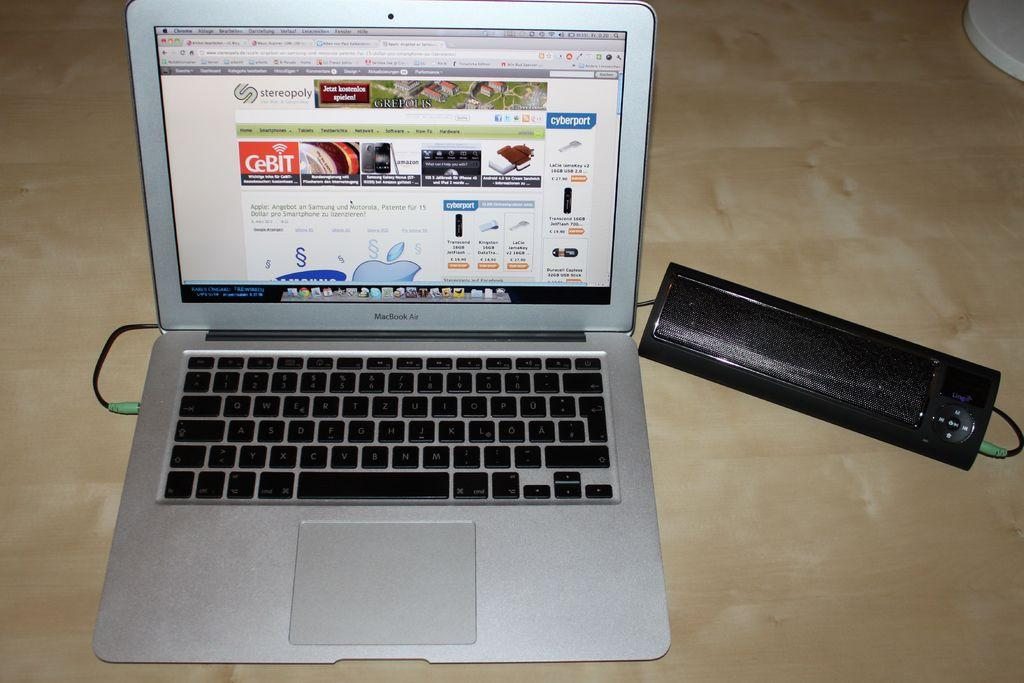<image>
Provide a brief description of the given image. A macbook on the website stereopoly which is an online retailer. 